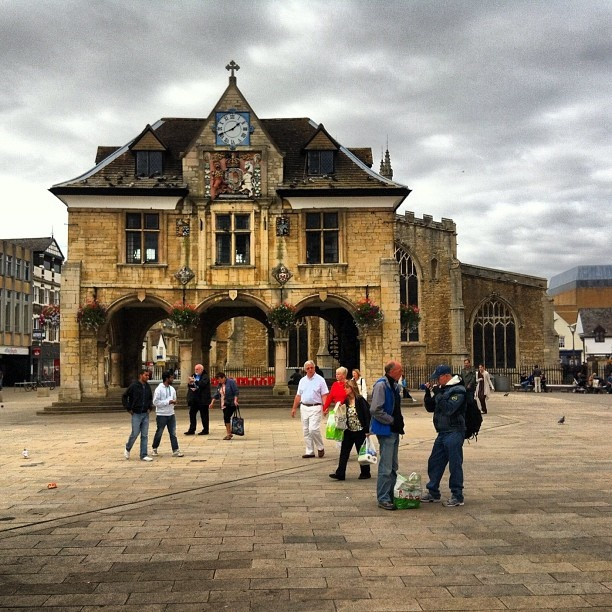Describe the objects in this image and their specific colors. I can see people in lightgray, black, gray, navy, and maroon tones, people in lightgray, black, gray, navy, and darkblue tones, people in lightgray, darkgray, brown, and tan tones, people in lightgray, black, gray, blue, and maroon tones, and people in lightgray, black, maroon, and gray tones in this image. 